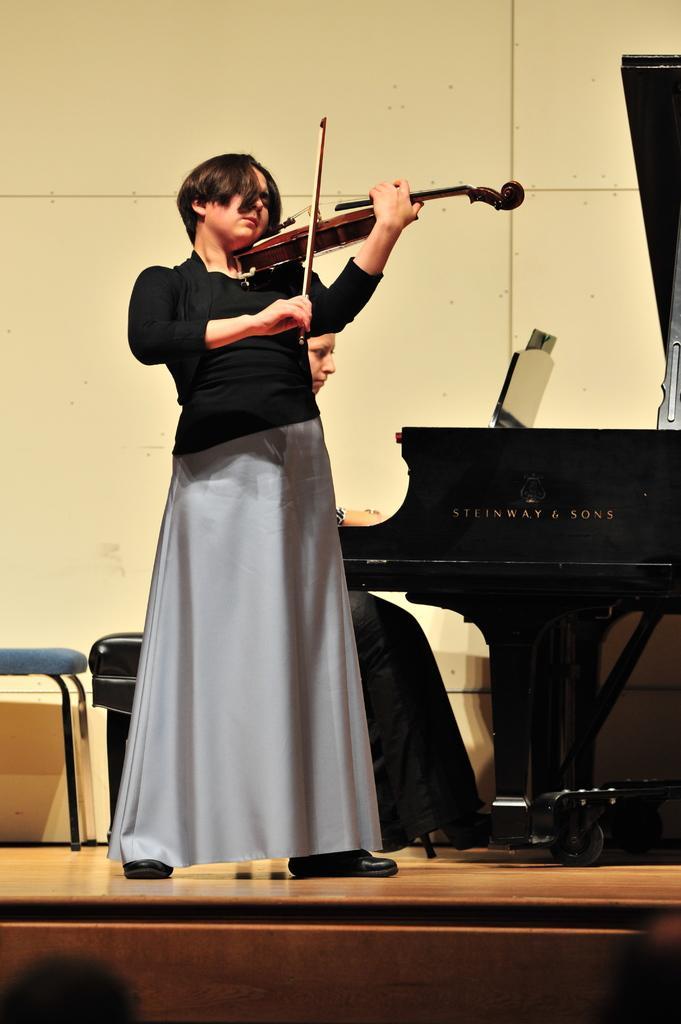Please provide a concise description of this image. There is a woman wearing black dress is standing and playing violin which is in her hand and there is another person sitting behind her is playing piano. 